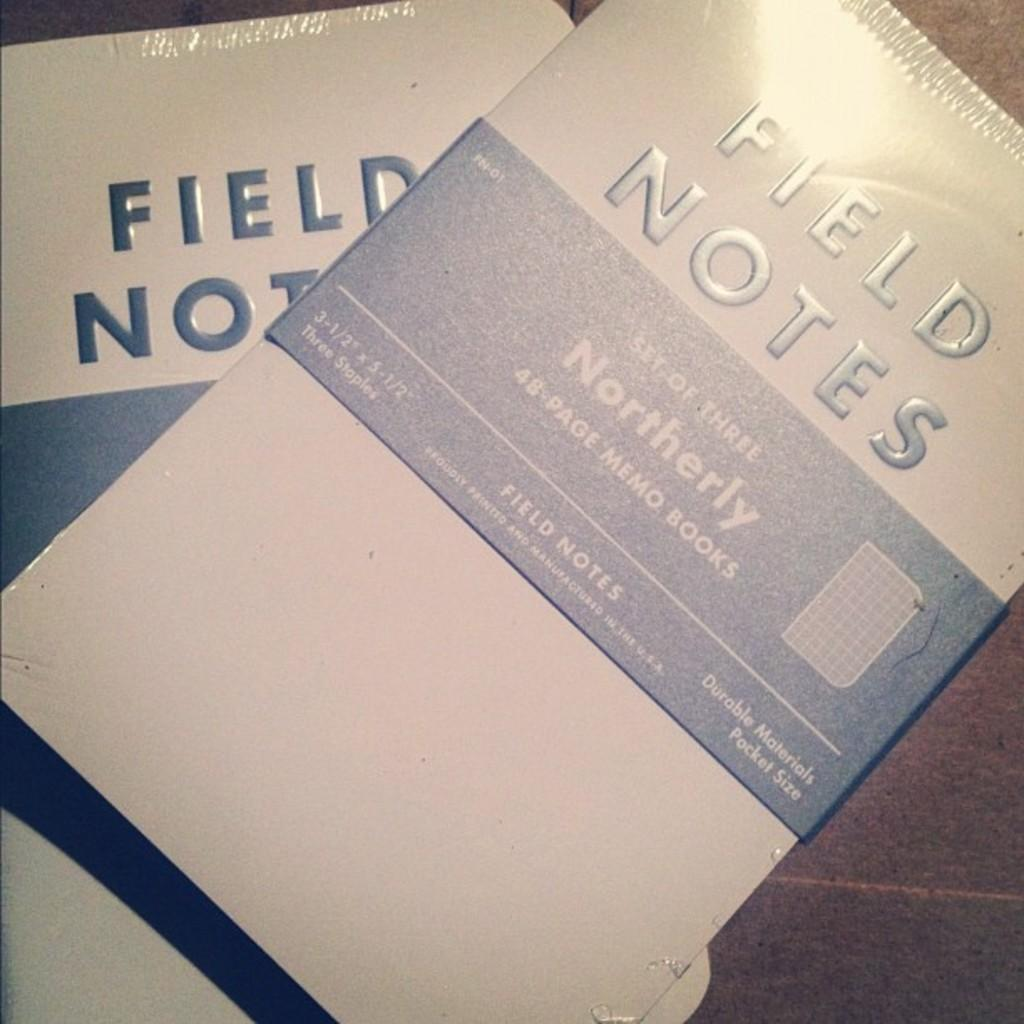What objects can be seen in the image? There are books in the image. Where are the books located? The books are placed on a table. What type of balloon is floating above the books in the image? There is no balloon present in the image. What color are the berries on the books in the image? There are no berries present on the books in the image. 